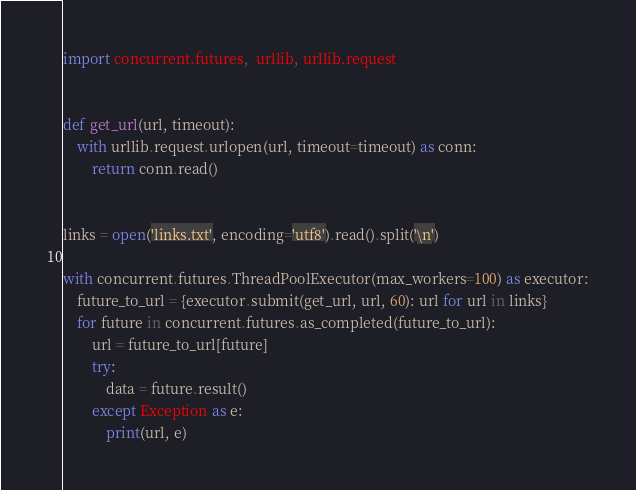Convert code to text. <code><loc_0><loc_0><loc_500><loc_500><_Python_>import concurrent.futures,  urllib, urllib.request


def get_url(url, timeout):
    with urllib.request.urlopen(url, timeout=timeout) as conn:
        return conn.read()


links = open('links.txt', encoding='utf8').read().split('\n')

with concurrent.futures.ThreadPoolExecutor(max_workers=100) as executor:
    future_to_url = {executor.submit(get_url, url, 60): url for url in links}
    for future in concurrent.futures.as_completed(future_to_url):
        url = future_to_url[future]
        try:
            data = future.result()
        except Exception as e:
            print(url, e)</code> 